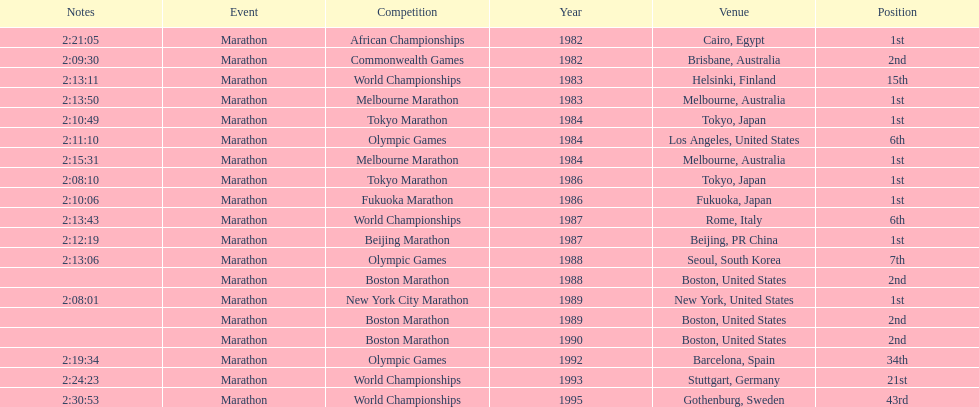What were the number of times the venue was located in the united states? 5. 